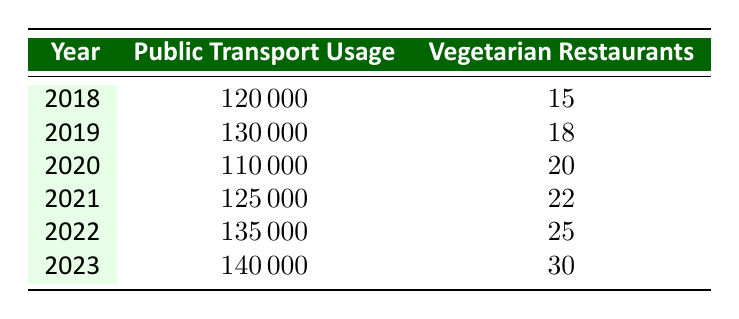What was the public transportation usage in 2020? The table lists the public transportation usage for 2020 as 110000.
Answer: 110000 How many vegetarian restaurants were there in 2021? According to the table, in 2021, there were 22 vegetarian restaurants.
Answer: 22 What is the difference in public transportation usage between 2018 and 2022? The usage in 2018 is 120000 and in 2022 is 135000. The difference is 135000 - 120000 = 15000.
Answer: 15000 What was the average number of vegetarian restaurants from 2018 to 2023? To find the average, sum the vegetarian restaurants: 15 + 18 + 20 + 22 + 25 + 30 = 130. There are 6 years, so the average is 130 / 6 ≈ 21.67, which can be rounded to 22.
Answer: 22 Did public transportation usage increase every year from 2018 to 2023? By checking the numbers: 120000 (2018) to 130000 (2019) is an increase, but then it decreases to 110000 in 2020. Thus, it did not increase every year.
Answer: No What year saw the greatest increase in vegetarian restaurants? Checking the restaurant growth: from 2018 to 2019, growth was 3; from 2019 to 2020, it was 2; from 2020 to 2021, it was 2; from 2021 to 2022, it was 3; and from 2022 to 2023, it was 5. The largest growth occurred from 2022 to 2023 with an increase of 5.
Answer: 2023 How many total vegetarian restaurants were there from 2018 to 2023? Totaling up the vegetarian restaurants gives: 15 + 18 + 20 + 22 + 25 + 30 = 130.
Answer: 130 Was the public transport usage in 2023 higher than in 2019? In 2019, the usage was 130000, while in 2023 it is 140000. Since 140000 > 130000, the answer is yes.
Answer: Yes In which year did public transportation usage first go below 120000? From the data, public transportation usage only went below 120000 in 2020 at 110000.
Answer: 2020 